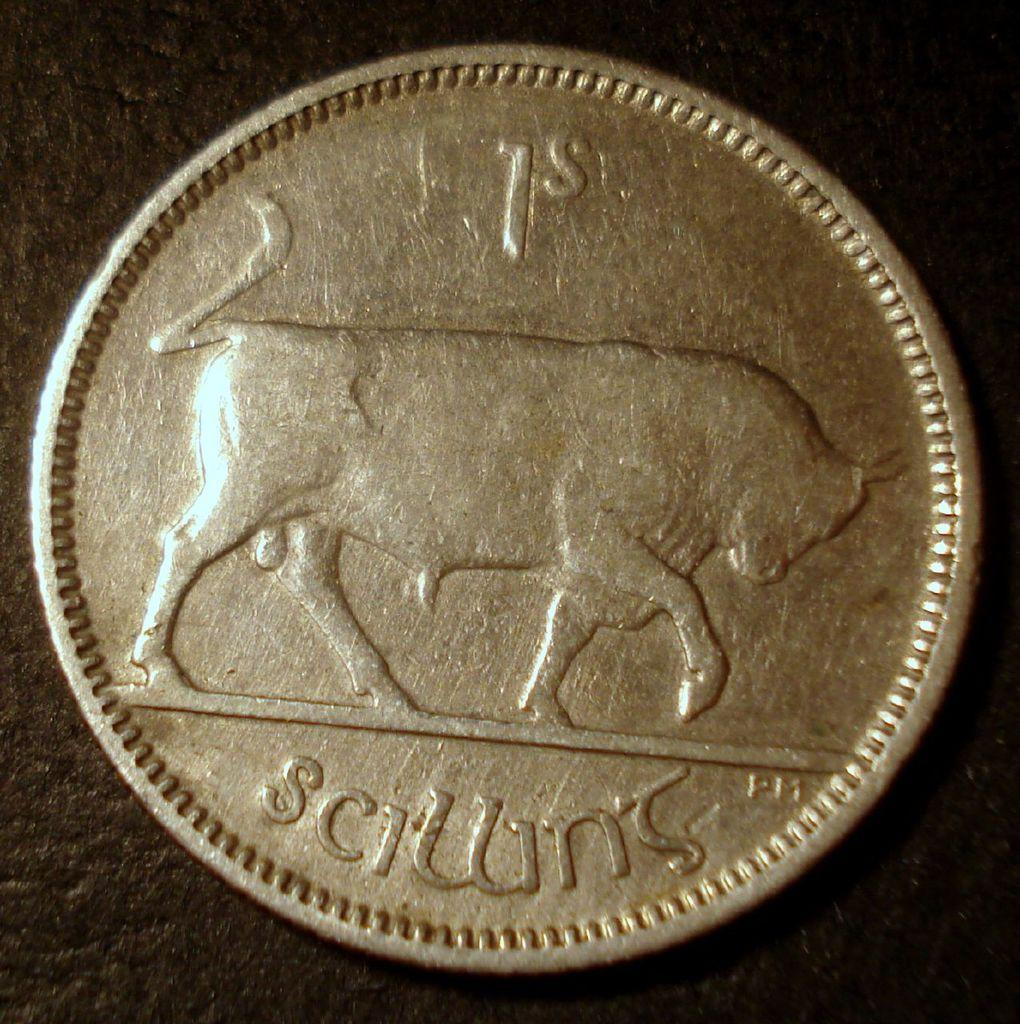<image>
Create a compact narrative representing the image presented. gold coin with picture of bull and words 1st scillins 